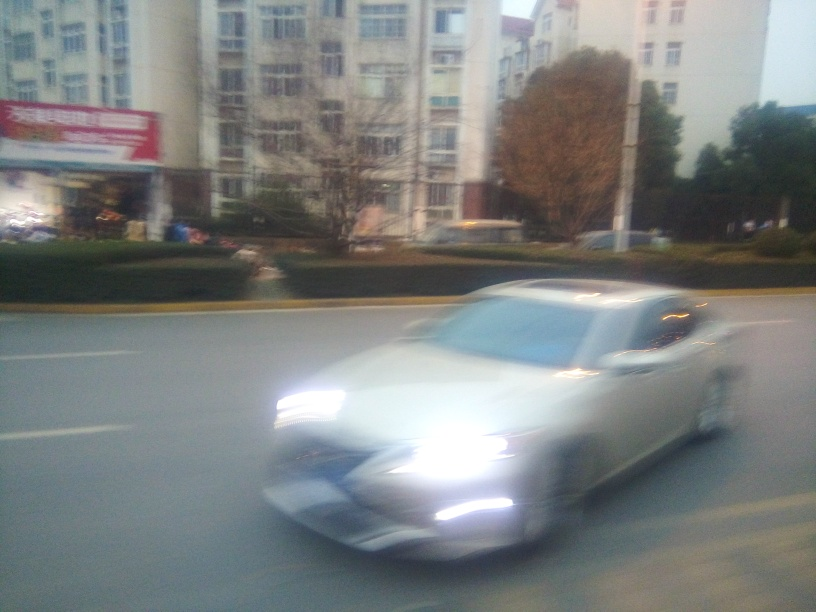What is the problem with the focus?
A. Blurry image overall.
B. Clear and sharp focus.
C. Soft focus.
Answer with the option's letter from the given choices directly. The correct option is A. The entire image appears to be blurry. This may be due to movement during the exposure, resulting in a lack of sharpness and fine detail throughout the scene, which is particularly noticeable in both the moving car and the static background. 